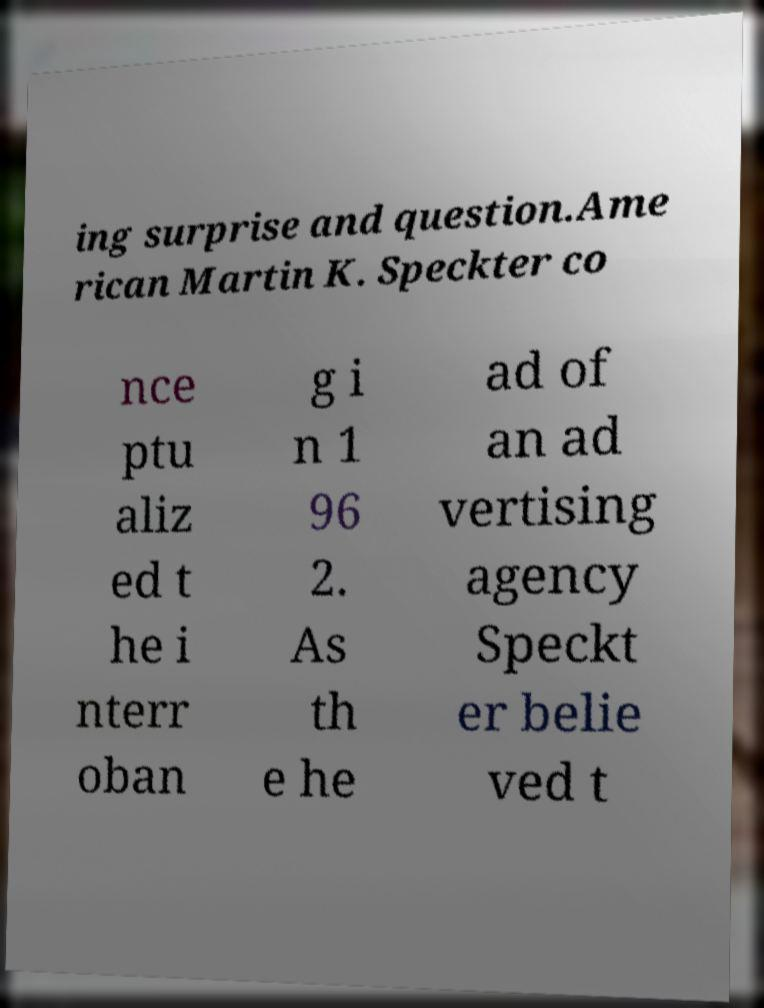Could you extract and type out the text from this image? ing surprise and question.Ame rican Martin K. Speckter co nce ptu aliz ed t he i nterr oban g i n 1 96 2. As th e he ad of an ad vertising agency Speckt er belie ved t 